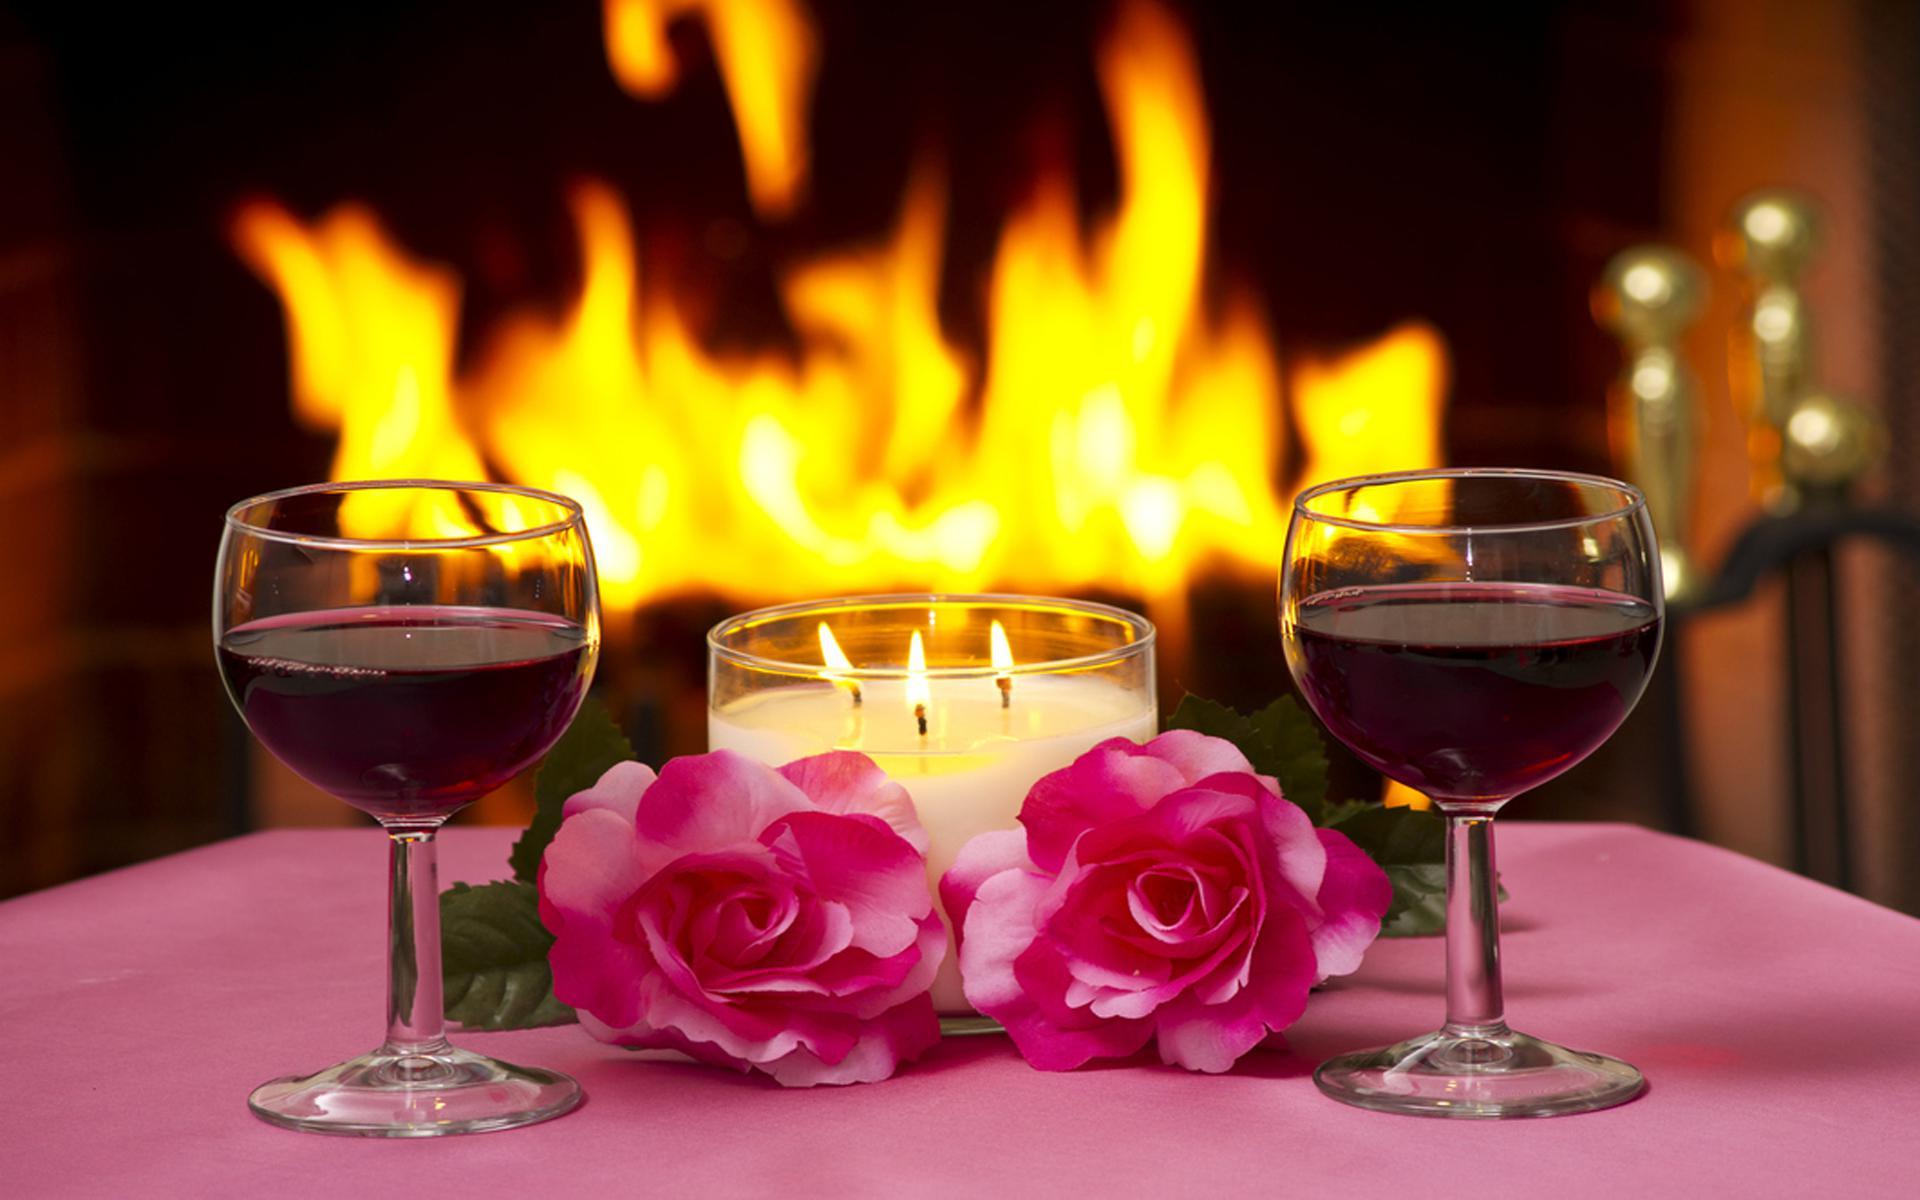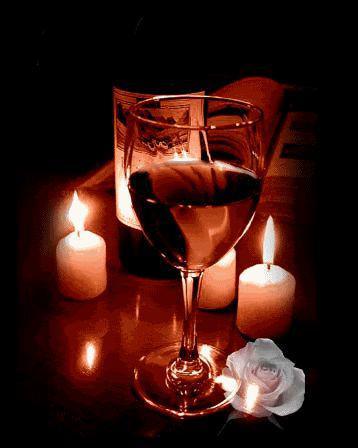The first image is the image on the left, the second image is the image on the right. Assess this claim about the two images: "there are four wine glasses total in both". Correct or not? Answer yes or no. No. The first image is the image on the left, the second image is the image on the right. For the images shown, is this caption "There is an obvious fireplace in the background of one of the images." true? Answer yes or no. Yes. 